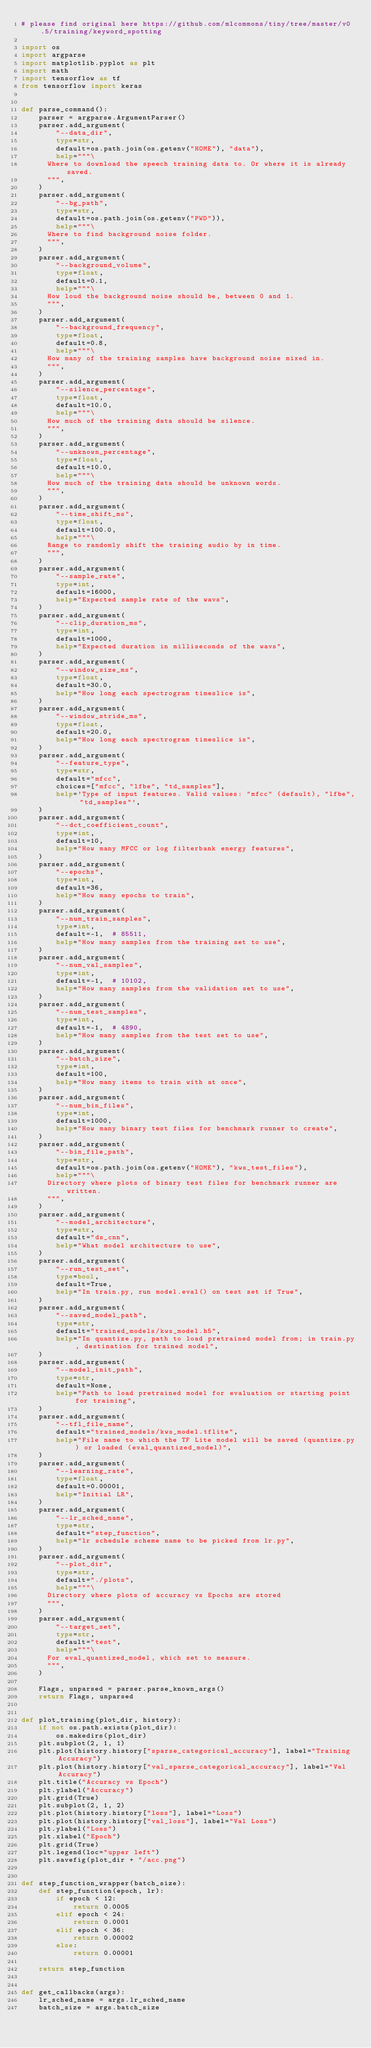Convert code to text. <code><loc_0><loc_0><loc_500><loc_500><_Python_># please find original here https://github.com/mlcommons/tiny/tree/master/v0.5/training/keyword_spotting

import os
import argparse
import matplotlib.pyplot as plt
import math
import tensorflow as tf
from tensorflow import keras


def parse_command():
    parser = argparse.ArgumentParser()
    parser.add_argument(
        "--data_dir",
        type=str,
        default=os.path.join(os.getenv("HOME"), "data"),
        help="""\
      Where to download the speech training data to. Or where it is already saved.
      """,
    )
    parser.add_argument(
        "--bg_path",
        type=str,
        default=os.path.join(os.getenv("PWD")),
        help="""\
      Where to find background noise folder.
      """,
    )
    parser.add_argument(
        "--background_volume",
        type=float,
        default=0.1,
        help="""\
      How loud the background noise should be, between 0 and 1.
      """,
    )
    parser.add_argument(
        "--background_frequency",
        type=float,
        default=0.8,
        help="""\
      How many of the training samples have background noise mixed in.
      """,
    )
    parser.add_argument(
        "--silence_percentage",
        type=float,
        default=10.0,
        help="""\
      How much of the training data should be silence.
      """,
    )
    parser.add_argument(
        "--unknown_percentage",
        type=float,
        default=10.0,
        help="""\
      How much of the training data should be unknown words.
      """,
    )
    parser.add_argument(
        "--time_shift_ms",
        type=float,
        default=100.0,
        help="""\
      Range to randomly shift the training audio by in time.
      """,
    )
    parser.add_argument(
        "--sample_rate",
        type=int,
        default=16000,
        help="Expected sample rate of the wavs",
    )
    parser.add_argument(
        "--clip_duration_ms",
        type=int,
        default=1000,
        help="Expected duration in milliseconds of the wavs",
    )
    parser.add_argument(
        "--window_size_ms",
        type=float,
        default=30.0,
        help="How long each spectrogram timeslice is",
    )
    parser.add_argument(
        "--window_stride_ms",
        type=float,
        default=20.0,
        help="How long each spectrogram timeslice is",
    )
    parser.add_argument(
        "--feature_type",
        type=str,
        default="mfcc",
        choices=["mfcc", "lfbe", "td_samples"],
        help='Type of input features. Valid values: "mfcc" (default), "lfbe", "td_samples"',
    )
    parser.add_argument(
        "--dct_coefficient_count",
        type=int,
        default=10,
        help="How many MFCC or log filterbank energy features",
    )
    parser.add_argument(
        "--epochs",
        type=int,
        default=36,
        help="How many epochs to train",
    )
    parser.add_argument(
        "--num_train_samples",
        type=int,
        default=-1,  # 85511,
        help="How many samples from the training set to use",
    )
    parser.add_argument(
        "--num_val_samples",
        type=int,
        default=-1,  # 10102,
        help="How many samples from the validation set to use",
    )
    parser.add_argument(
        "--num_test_samples",
        type=int,
        default=-1,  # 4890,
        help="How many samples from the test set to use",
    )
    parser.add_argument(
        "--batch_size",
        type=int,
        default=100,
        help="How many items to train with at once",
    )
    parser.add_argument(
        "--num_bin_files",
        type=int,
        default=1000,
        help="How many binary test files for benchmark runner to create",
    )
    parser.add_argument(
        "--bin_file_path",
        type=str,
        default=os.path.join(os.getenv("HOME"), "kws_test_files"),
        help="""\
      Directory where plots of binary test files for benchmark runner are written.
      """,
    )
    parser.add_argument(
        "--model_architecture",
        type=str,
        default="ds_cnn",
        help="What model architecture to use",
    )
    parser.add_argument(
        "--run_test_set",
        type=bool,
        default=True,
        help="In train.py, run model.eval() on test set if True",
    )
    parser.add_argument(
        "--saved_model_path",
        type=str,
        default="trained_models/kws_model.h5",
        help="In quantize.py, path to load pretrained model from; in train.py, destination for trained model",
    )
    parser.add_argument(
        "--model_init_path",
        type=str,
        default=None,
        help="Path to load pretrained model for evaluation or starting point for training",
    )
    parser.add_argument(
        "--tfl_file_name",
        default="trained_models/kws_model.tflite",
        help="File name to which the TF Lite model will be saved (quantize.py) or loaded (eval_quantized_model)",
    )
    parser.add_argument(
        "--learning_rate",
        type=float,
        default=0.00001,
        help="Initial LR",
    )
    parser.add_argument(
        "--lr_sched_name",
        type=str,
        default="step_function",
        help="lr schedule scheme name to be picked from lr.py",
    )
    parser.add_argument(
        "--plot_dir",
        type=str,
        default="./plots",
        help="""\
      Directory where plots of accuracy vs Epochs are stored
      """,
    )
    parser.add_argument(
        "--target_set",
        type=str,
        default="test",
        help="""\
      For eval_quantized_model, which set to measure.
      """,
    )

    Flags, unparsed = parser.parse_known_args()
    return Flags, unparsed


def plot_training(plot_dir, history):
    if not os.path.exists(plot_dir):
        os.makedirs(plot_dir)
    plt.subplot(2, 1, 1)
    plt.plot(history.history["sparse_categorical_accuracy"], label="Training Accuracy")
    plt.plot(history.history["val_sparse_categorical_accuracy"], label="Val Accuracy")
    plt.title("Accuracy vs Epoch")
    plt.ylabel("Accuracy")
    plt.grid(True)
    plt.subplot(2, 1, 2)
    plt.plot(history.history["loss"], label="Loss")
    plt.plot(history.history["val_loss"], label="Val Loss")
    plt.ylabel("Loss")
    plt.xlabel("Epoch")
    plt.grid(True)
    plt.legend(loc="upper left")
    plt.savefig(plot_dir + "/acc.png")


def step_function_wrapper(batch_size):
    def step_function(epoch, lr):
        if epoch < 12:
            return 0.0005
        elif epoch < 24:
            return 0.0001
        elif epoch < 36:
            return 0.00002
        else:
            return 0.00001

    return step_function


def get_callbacks(args):
    lr_sched_name = args.lr_sched_name
    batch_size = args.batch_size</code> 